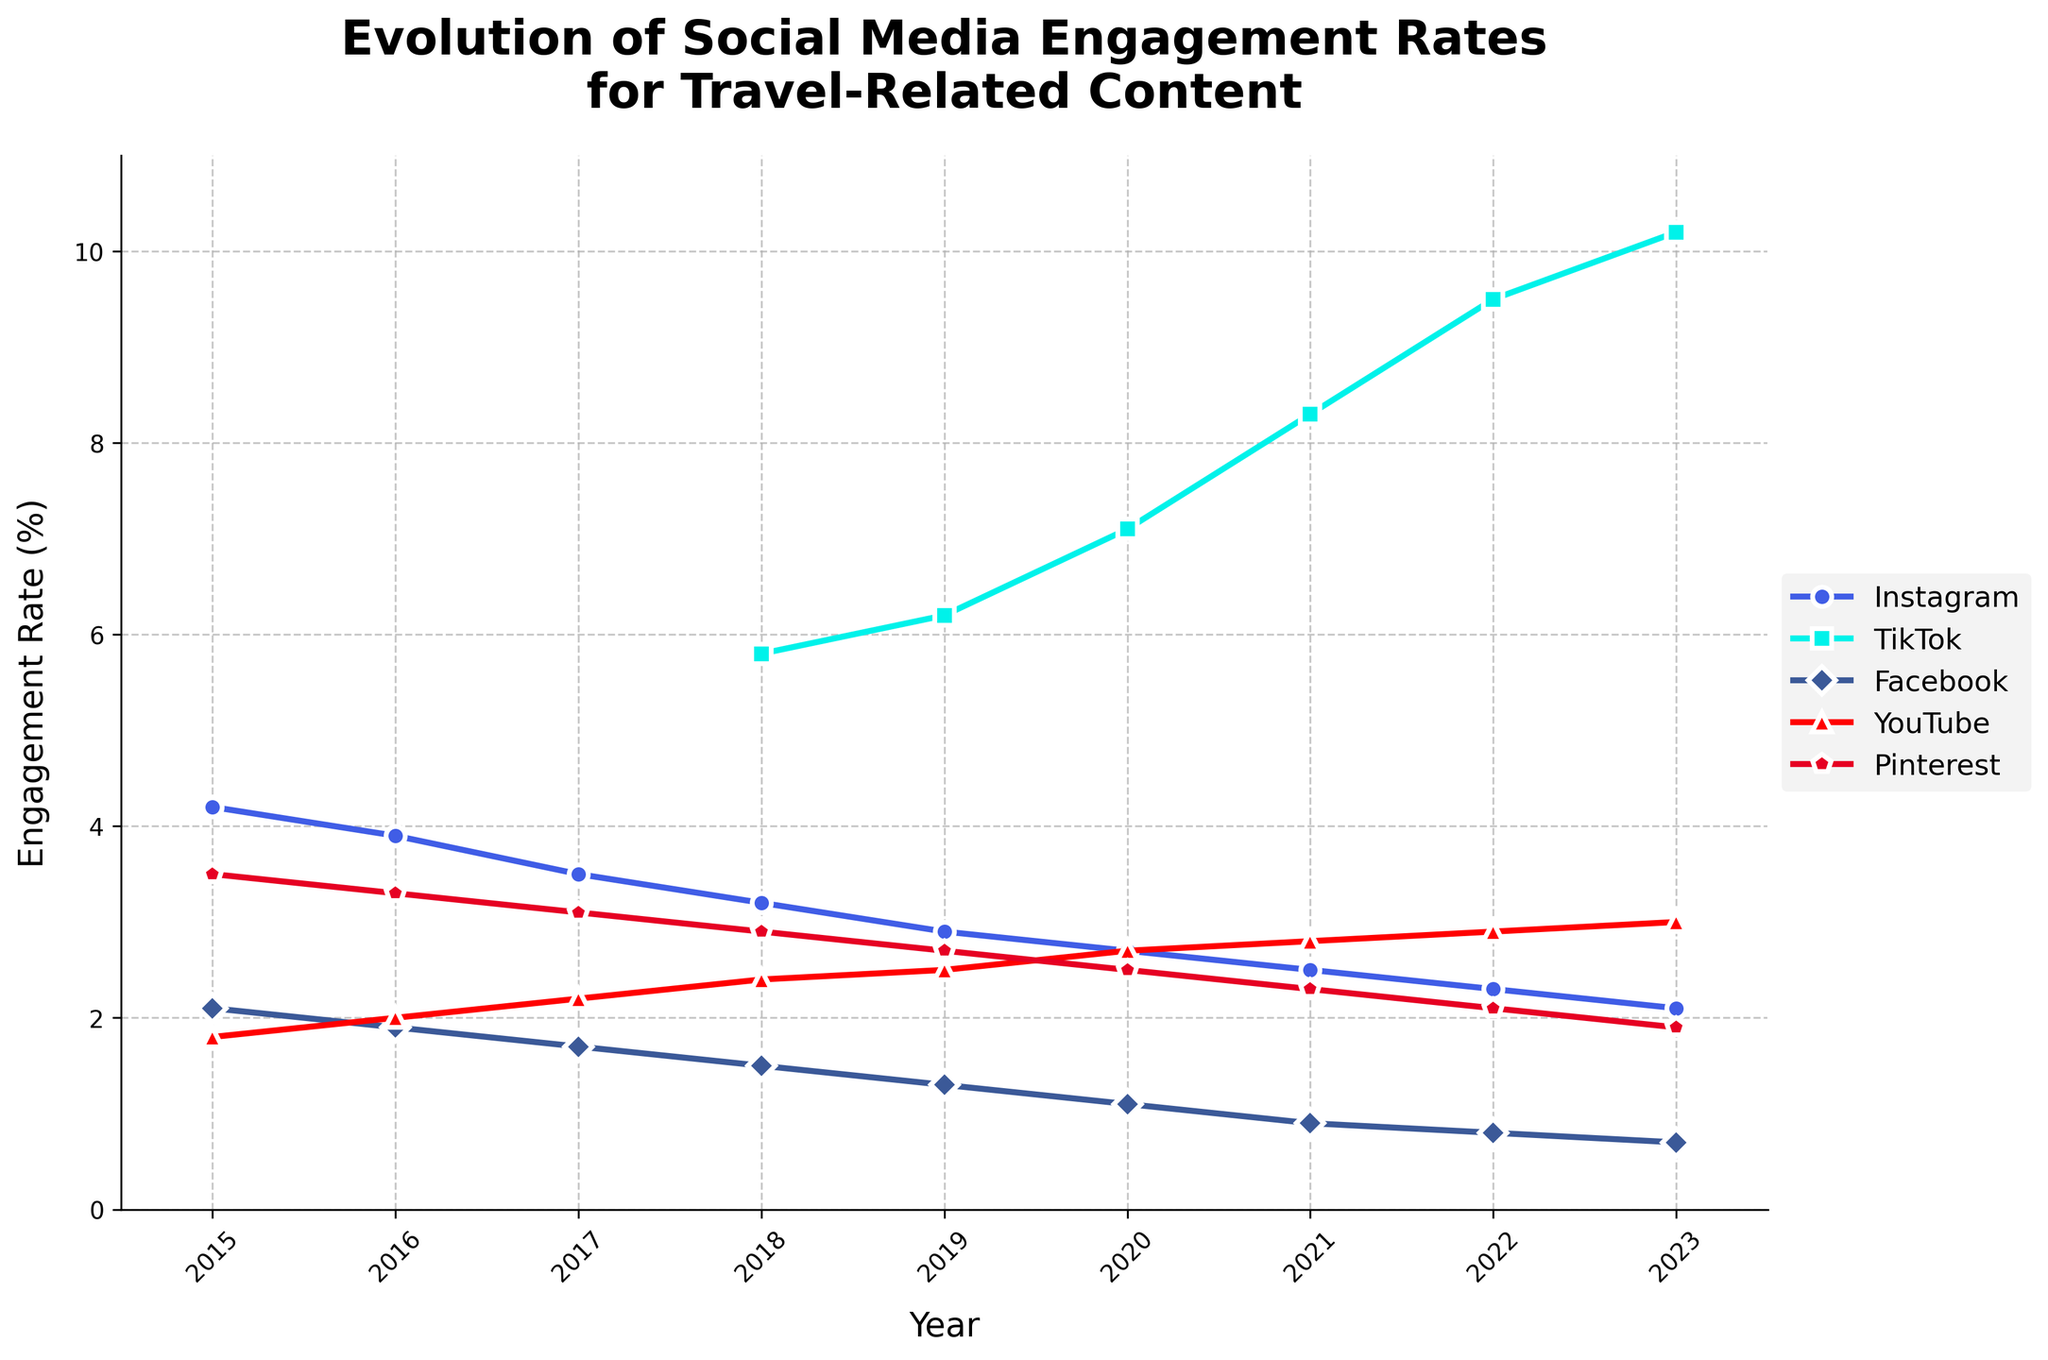What is the overall trend of Instagram's engagement rate from 2015 to 2023? Instagram's engagement rate shows a decreasing trend from 4.2% in 2015 to 2.1% in 2023. This decline can be observed by following the plot line for Instagram from the start to the end.
Answer: Decrease Which year did TikTok start showing engagement rates in the data, and what was the engagement rate that year? TikTok engagement data starts from 2018, with an engagement rate of 5.8%. This can be identified by looking at the TikTok plot line, where it starts in 2018.
Answer: 2018, 5.8% Between 2015 and 2023, which platform saw the highest peak in engagement rate and what was the value? TikTok saw the highest peak engagement rate at 10.2% in 2023. This is evident from the TikTok plot line, which reaches its highest point at the end of the timeline.
Answer: TikTok, 10.2% Compare the engagement rate of Facebook and YouTube in 2020. Which one is higher, and by how much? In 2020, Facebook's engagement rate was 1.1% and YouTube's was 2.7%. By subtracting Facebook’s rate from YouTube’s rate (2.7% - 1.1%), we find that YouTube’s rate was higher by 1.6%.
Answer: YouTube, 1.6% Which platform showed the most consistent decline in engagement rate over the years, and what is the decrease? Instagram experienced the most consistent decline from 4.2% in 2015 to 2.1% in 2023, a total decrease of 2.1%. This is determined by tracing the Instagram plot line, which continuously descends over the period.
Answer: Instagram, 2.1% In which year did Pinterest's engagement rate drop below 2%, and was there any recovery afterwards? Pinterest's engagement rate dropped below 2% in 2023, reaching 1.9%. The plot line does not show any recovery past this point, as 2023 is the latest data year presented.
Answer: 2023, no Calculate the average engagement rate of YouTube from 2015 to 2023. The engagement rates for YouTube from 2015 to 2023 are 1.8%, 2.0%, 2.2%, 2.4%, 2.5%, 2.7%, 2.8%, 2.9%, and 3.0%. Summing these values gives 22.3%, and dividing by the number of years (9) gives the average engagement rate of 2.48%.
Answer: 2.48% Compare the engagement rates of Instagram and TikTok in 2022. Which has the higher engagement rate and by how much? In 2022, Instagram has an engagement rate of 2.3% while TikTok has 9.5%. By subtracting Instagram's rate from TikTok's rate (9.5% - 2.3%), we find that TikTok's rate is higher by 7.2%.
Answer: TikTok, 7.2% What is the general visual trend for Facebook's engagement rate over the years? Visually, Facebook's engagement rate shows a consistent downward trend from 2.1% in 2015 to 0.7% in 2023. This can be seen by observing the downward slope of the Facebook plot line over the years.
Answer: Decrease 